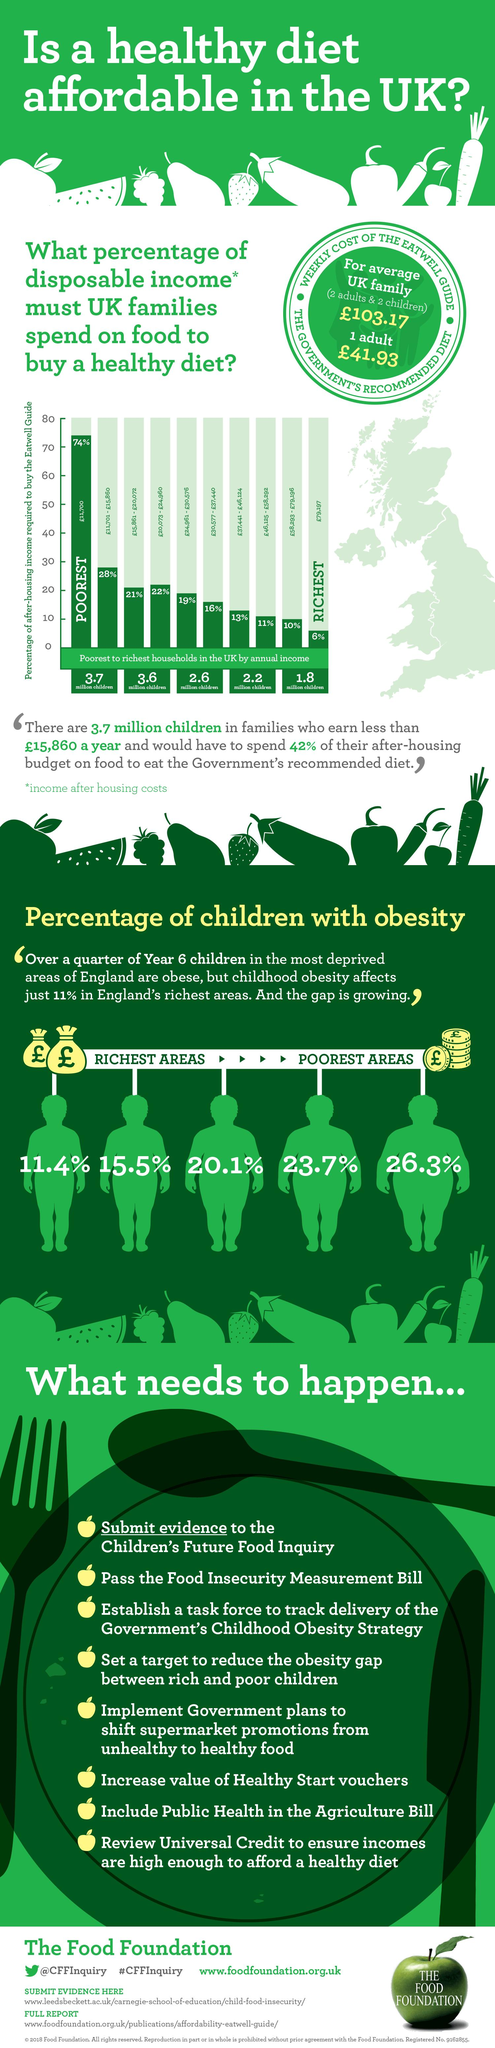Indicate a few pertinent items in this graphic. According to a recent study, 74% of the income of the poorest people is necessary to purchase a healthy diet. In England's poorest areas, obesity prevalence is 26.3%. According to recent studies, wealthy individuals are required to spend just 6% of their income in order to maintain a healthy and balanced diet. 